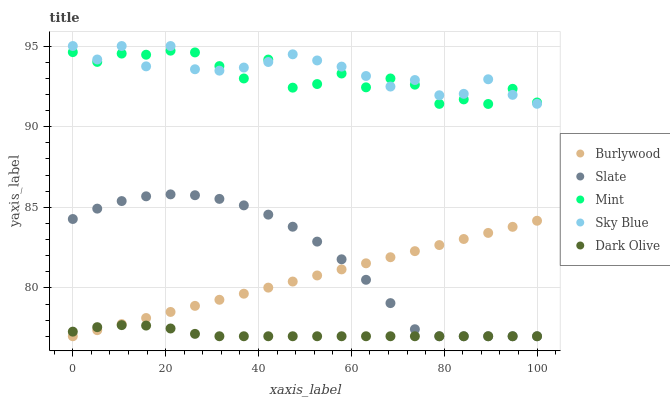Does Dark Olive have the minimum area under the curve?
Answer yes or no. Yes. Does Sky Blue have the maximum area under the curve?
Answer yes or no. Yes. Does Slate have the minimum area under the curve?
Answer yes or no. No. Does Slate have the maximum area under the curve?
Answer yes or no. No. Is Burlywood the smoothest?
Answer yes or no. Yes. Is Mint the roughest?
Answer yes or no. Yes. Is Sky Blue the smoothest?
Answer yes or no. No. Is Sky Blue the roughest?
Answer yes or no. No. Does Burlywood have the lowest value?
Answer yes or no. Yes. Does Sky Blue have the lowest value?
Answer yes or no. No. Does Sky Blue have the highest value?
Answer yes or no. Yes. Does Slate have the highest value?
Answer yes or no. No. Is Dark Olive less than Sky Blue?
Answer yes or no. Yes. Is Mint greater than Dark Olive?
Answer yes or no. Yes. Does Sky Blue intersect Mint?
Answer yes or no. Yes. Is Sky Blue less than Mint?
Answer yes or no. No. Is Sky Blue greater than Mint?
Answer yes or no. No. Does Dark Olive intersect Sky Blue?
Answer yes or no. No. 